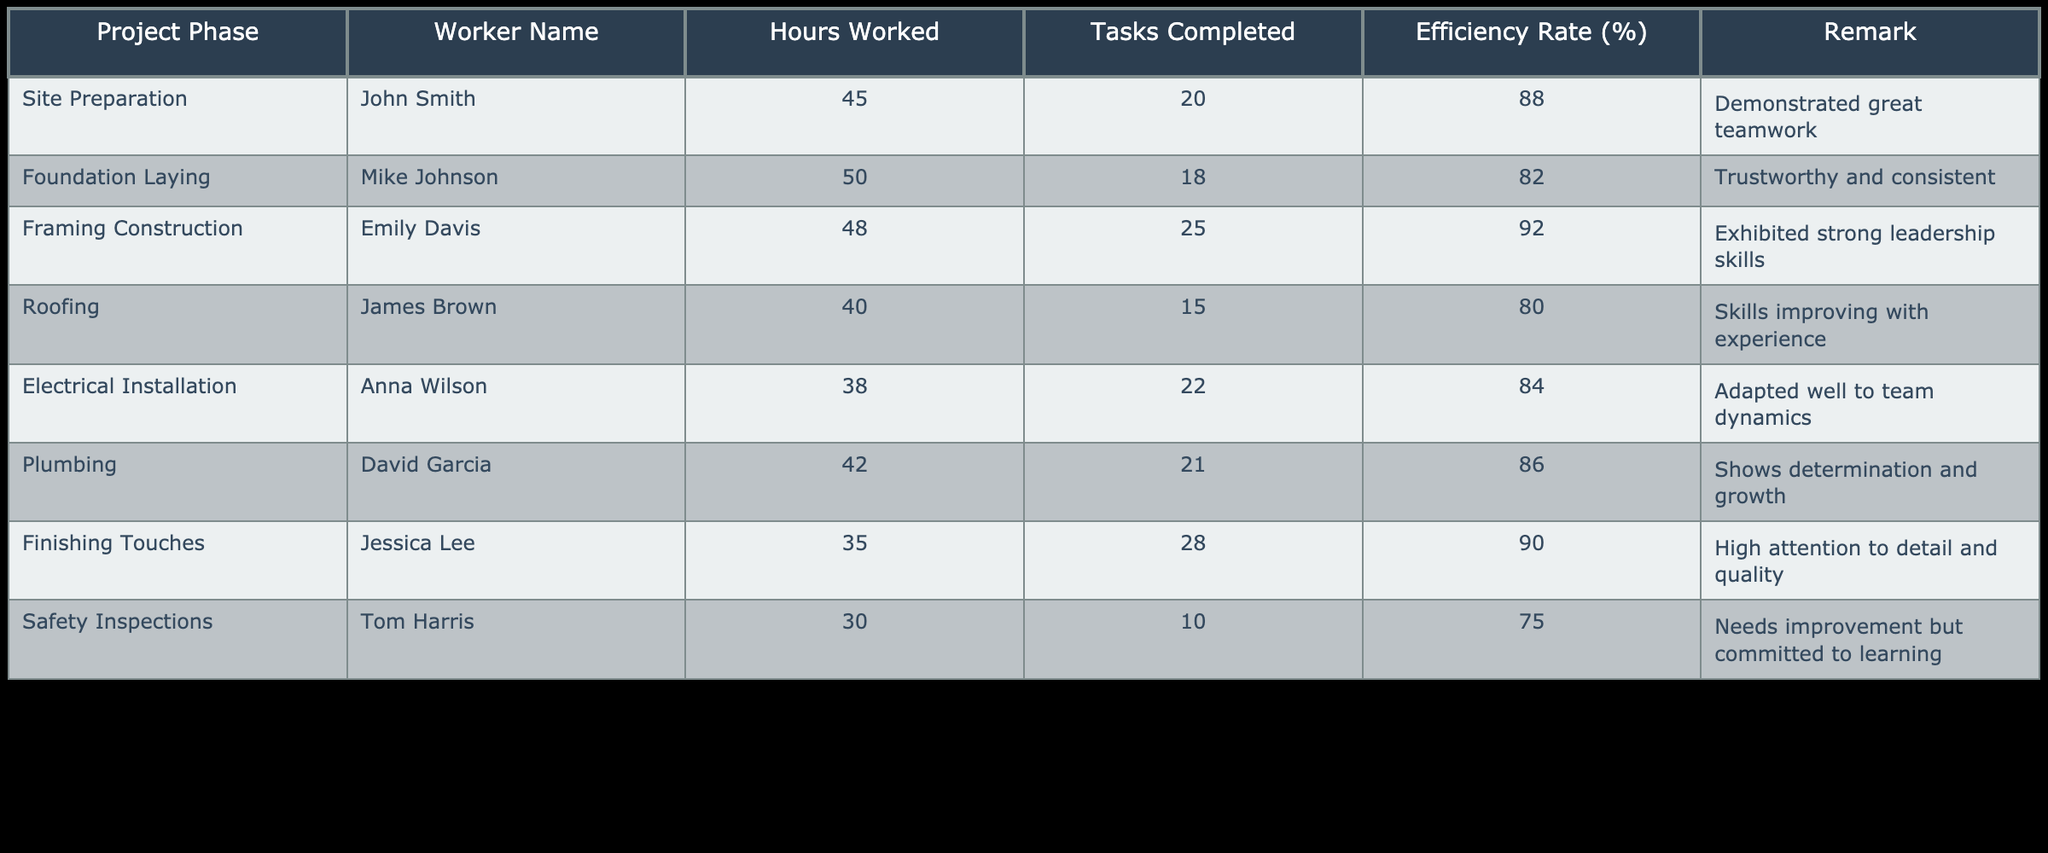What is the efficiency rate for Emily Davis during framing construction? From the table, under the "Efficiency Rate (%)" column, Emily Davis has a listed efficiency rate of 92 during the framing construction phase.
Answer: 92 Who worked the most hours, and how many hours did they work? By looking at the "Hours Worked" column, Mike Johnson worked the most with a total of 50 hours during the foundation laying phase.
Answer: Mike Johnson, 50 hours What is the average efficiency rate for all workers? To find the average efficiency rate, we sum the efficiency rates: (88 + 82 + 92 + 80 + 84 + 86 + 90 + 75) and divide by 8, which equals 83.875. Therefore, the average efficiency rate is approximately 84 when rounded.
Answer: 84 Did any worker complete more than 25 tasks? From the table, Jessica Lee completed 28 tasks during the finishing touches phase, which is more than 25. Thus, the answer is yes.
Answer: Yes How many hours did Tom Harris work, and what was his efficiency rate? Tom Harris worked a total of 30 hours in the safety inspections phase, and his efficiency rate was 75%. This information can be directly found in the respective columns of the table.
Answer: 30 hours, 75% Which worker demonstrated strong leadership skills? The table indicates that Emily Davis exhibited strong leadership skills during her work in the framing construction phase.
Answer: Emily Davis If we combine the tasks completed by David Garcia and Anna Wilson, how many tasks did they complete together? David Garcia completed 21 tasks, and Anna Wilson completed 22 tasks. The total when adding these is 21 + 22 = 43.
Answer: 43 Who has shown improvement with their skills in the roofing phase? The table states that James Brown, who worked in roofing, has been noted as having skills improving with experience, indicating his progress.
Answer: James Brown What is the difference in efficiency rates between the worker with the highest and the lowest efficiency rate? Emily Davis has the highest efficiency rate of 92, and Tom Harris has the lowest at 75. Calculating the difference gives us 92 - 75 = 17.
Answer: 17 